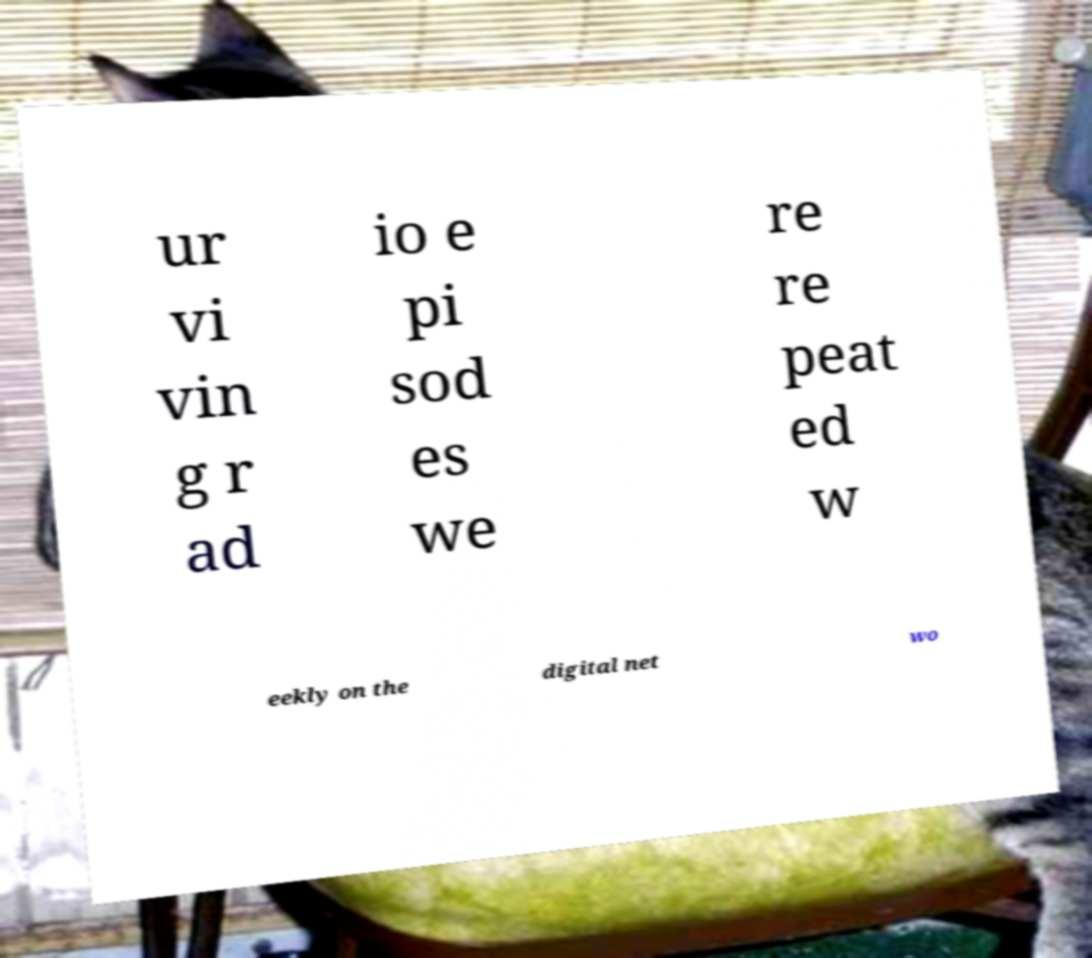What messages or text are displayed in this image? I need them in a readable, typed format. ur vi vin g r ad io e pi sod es we re re peat ed w eekly on the digital net wo 